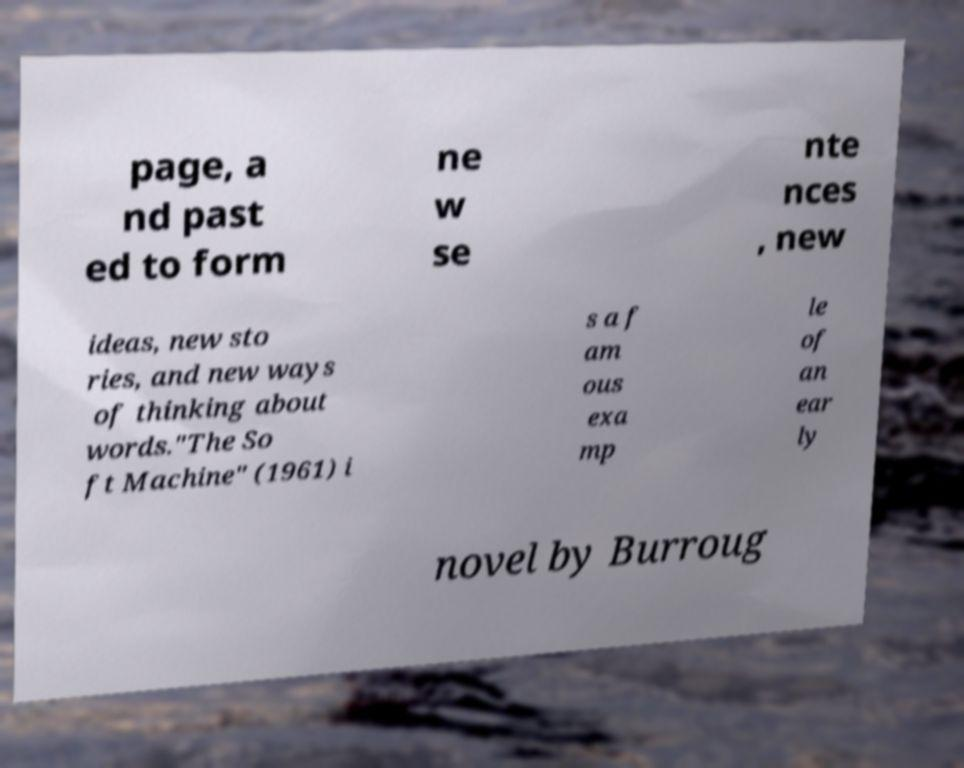What messages or text are displayed in this image? I need them in a readable, typed format. page, a nd past ed to form ne w se nte nces , new ideas, new sto ries, and new ways of thinking about words."The So ft Machine" (1961) i s a f am ous exa mp le of an ear ly novel by Burroug 